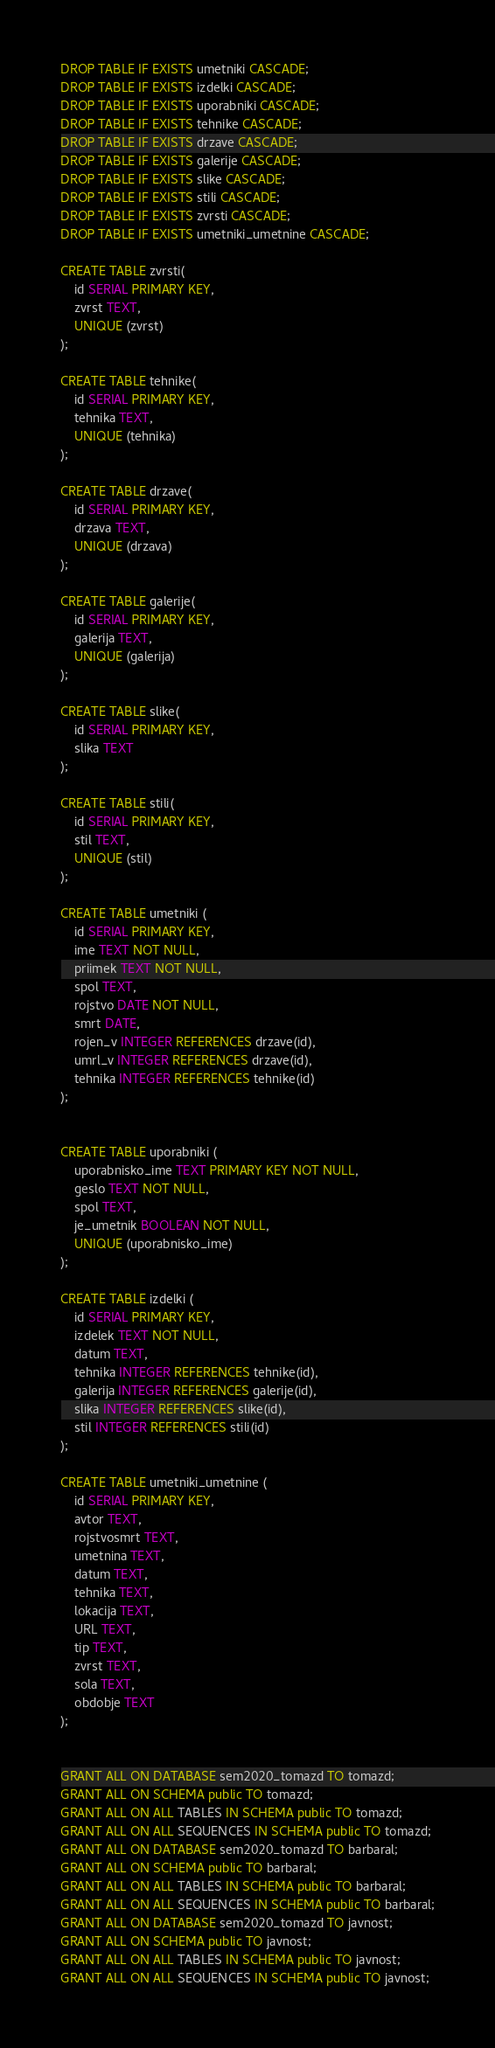Convert code to text. <code><loc_0><loc_0><loc_500><loc_500><_SQL_>DROP TABLE IF EXISTS umetniki CASCADE;
DROP TABLE IF EXISTS izdelki CASCADE;
DROP TABLE IF EXISTS uporabniki CASCADE;
DROP TABLE IF EXISTS tehnike CASCADE;
DROP TABLE IF EXISTS drzave CASCADE;
DROP TABLE IF EXISTS galerije CASCADE;
DROP TABLE IF EXISTS slike CASCADE;
DROP TABLE IF EXISTS stili CASCADE;
DROP TABLE IF EXISTS zvrsti CASCADE;
DROP TABLE IF EXISTS umetniki_umetnine CASCADE;

CREATE TABLE zvrsti(
    id SERIAL PRIMARY KEY,
    zvrst TEXT,
    UNIQUE (zvrst)
);

CREATE TABLE tehnike(
    id SERIAL PRIMARY KEY,
    tehnika TEXT,
    UNIQUE (tehnika)
);

CREATE TABLE drzave(
    id SERIAL PRIMARY KEY,
    drzava TEXT,
    UNIQUE (drzava)
);

CREATE TABLE galerije(
    id SERIAL PRIMARY KEY,
    galerija TEXT,
    UNIQUE (galerija)
);

CREATE TABLE slike(
    id SERIAL PRIMARY KEY,
    slika TEXT
);

CREATE TABLE stili(
    id SERIAL PRIMARY KEY,
    stil TEXT,
    UNIQUE (stil)
);

CREATE TABLE umetniki (
    id SERIAL PRIMARY KEY,
    ime TEXT NOT NULL,
    priimek TEXT NOT NULL,
    spol TEXT,
    rojstvo DATE NOT NULL,
    smrt DATE,
    rojen_v INTEGER REFERENCES drzave(id),
    umrl_v INTEGER REFERENCES drzave(id),
    tehnika INTEGER REFERENCES tehnike(id)
);


CREATE TABLE uporabniki (
    uporabnisko_ime TEXT PRIMARY KEY NOT NULL,
    geslo TEXT NOT NULL,
    spol TEXT,
    je_umetnik BOOLEAN NOT NULL,
    UNIQUE (uporabnisko_ime)
);

CREATE TABLE izdelki (
    id SERIAL PRIMARY KEY,
    izdelek TEXT NOT NULL,
    datum TEXT,
    tehnika INTEGER REFERENCES tehnike(id),
    galerija INTEGER REFERENCES galerije(id),
    slika INTEGER REFERENCES slike(id),
    stil INTEGER REFERENCES stili(id)
);

CREATE TABLE umetniki_umetnine (
    id SERIAL PRIMARY KEY,
    avtor TEXT,
    rojstvosmrt TEXT,
    umetnina TEXT,
    datum TEXT,
    tehnika TEXT,
    lokacija TEXT,
    URL TEXT,
    tip TEXT,
    zvrst TEXT,
    sola TEXT,
    obdobje TEXT
);


GRANT ALL ON DATABASE sem2020_tomazd TO tomazd;
GRANT ALL ON SCHEMA public TO tomazd;
GRANT ALL ON ALL TABLES IN SCHEMA public TO tomazd;
GRANT ALL ON ALL SEQUENCES IN SCHEMA public TO tomazd;
GRANT ALL ON DATABASE sem2020_tomazd TO barbaral;
GRANT ALL ON SCHEMA public TO barbaral;
GRANT ALL ON ALL TABLES IN SCHEMA public TO barbaral;
GRANT ALL ON ALL SEQUENCES IN SCHEMA public TO barbaral;
GRANT ALL ON DATABASE sem2020_tomazd TO javnost;
GRANT ALL ON SCHEMA public TO javnost;
GRANT ALL ON ALL TABLES IN SCHEMA public TO javnost;
GRANT ALL ON ALL SEQUENCES IN SCHEMA public TO javnost;
</code> 